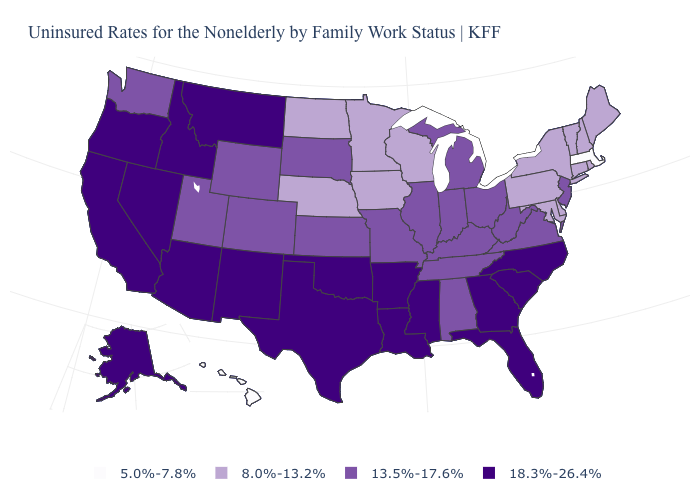What is the value of New Mexico?
Write a very short answer. 18.3%-26.4%. How many symbols are there in the legend?
Keep it brief. 4. Does Virginia have the same value as New Jersey?
Be succinct. Yes. What is the highest value in the USA?
Write a very short answer. 18.3%-26.4%. Which states hav the highest value in the West?
Write a very short answer. Alaska, Arizona, California, Idaho, Montana, Nevada, New Mexico, Oregon. What is the value of Arkansas?
Short answer required. 18.3%-26.4%. What is the value of Washington?
Be succinct. 13.5%-17.6%. Name the states that have a value in the range 5.0%-7.8%?
Be succinct. Hawaii, Massachusetts. What is the highest value in states that border New Jersey?
Answer briefly. 8.0%-13.2%. Is the legend a continuous bar?
Short answer required. No. Does Nevada have the highest value in the USA?
Write a very short answer. Yes. What is the lowest value in the USA?
Write a very short answer. 5.0%-7.8%. Name the states that have a value in the range 18.3%-26.4%?
Keep it brief. Alaska, Arizona, Arkansas, California, Florida, Georgia, Idaho, Louisiana, Mississippi, Montana, Nevada, New Mexico, North Carolina, Oklahoma, Oregon, South Carolina, Texas. Name the states that have a value in the range 18.3%-26.4%?
Give a very brief answer. Alaska, Arizona, Arkansas, California, Florida, Georgia, Idaho, Louisiana, Mississippi, Montana, Nevada, New Mexico, North Carolina, Oklahoma, Oregon, South Carolina, Texas. What is the value of Oregon?
Quick response, please. 18.3%-26.4%. 